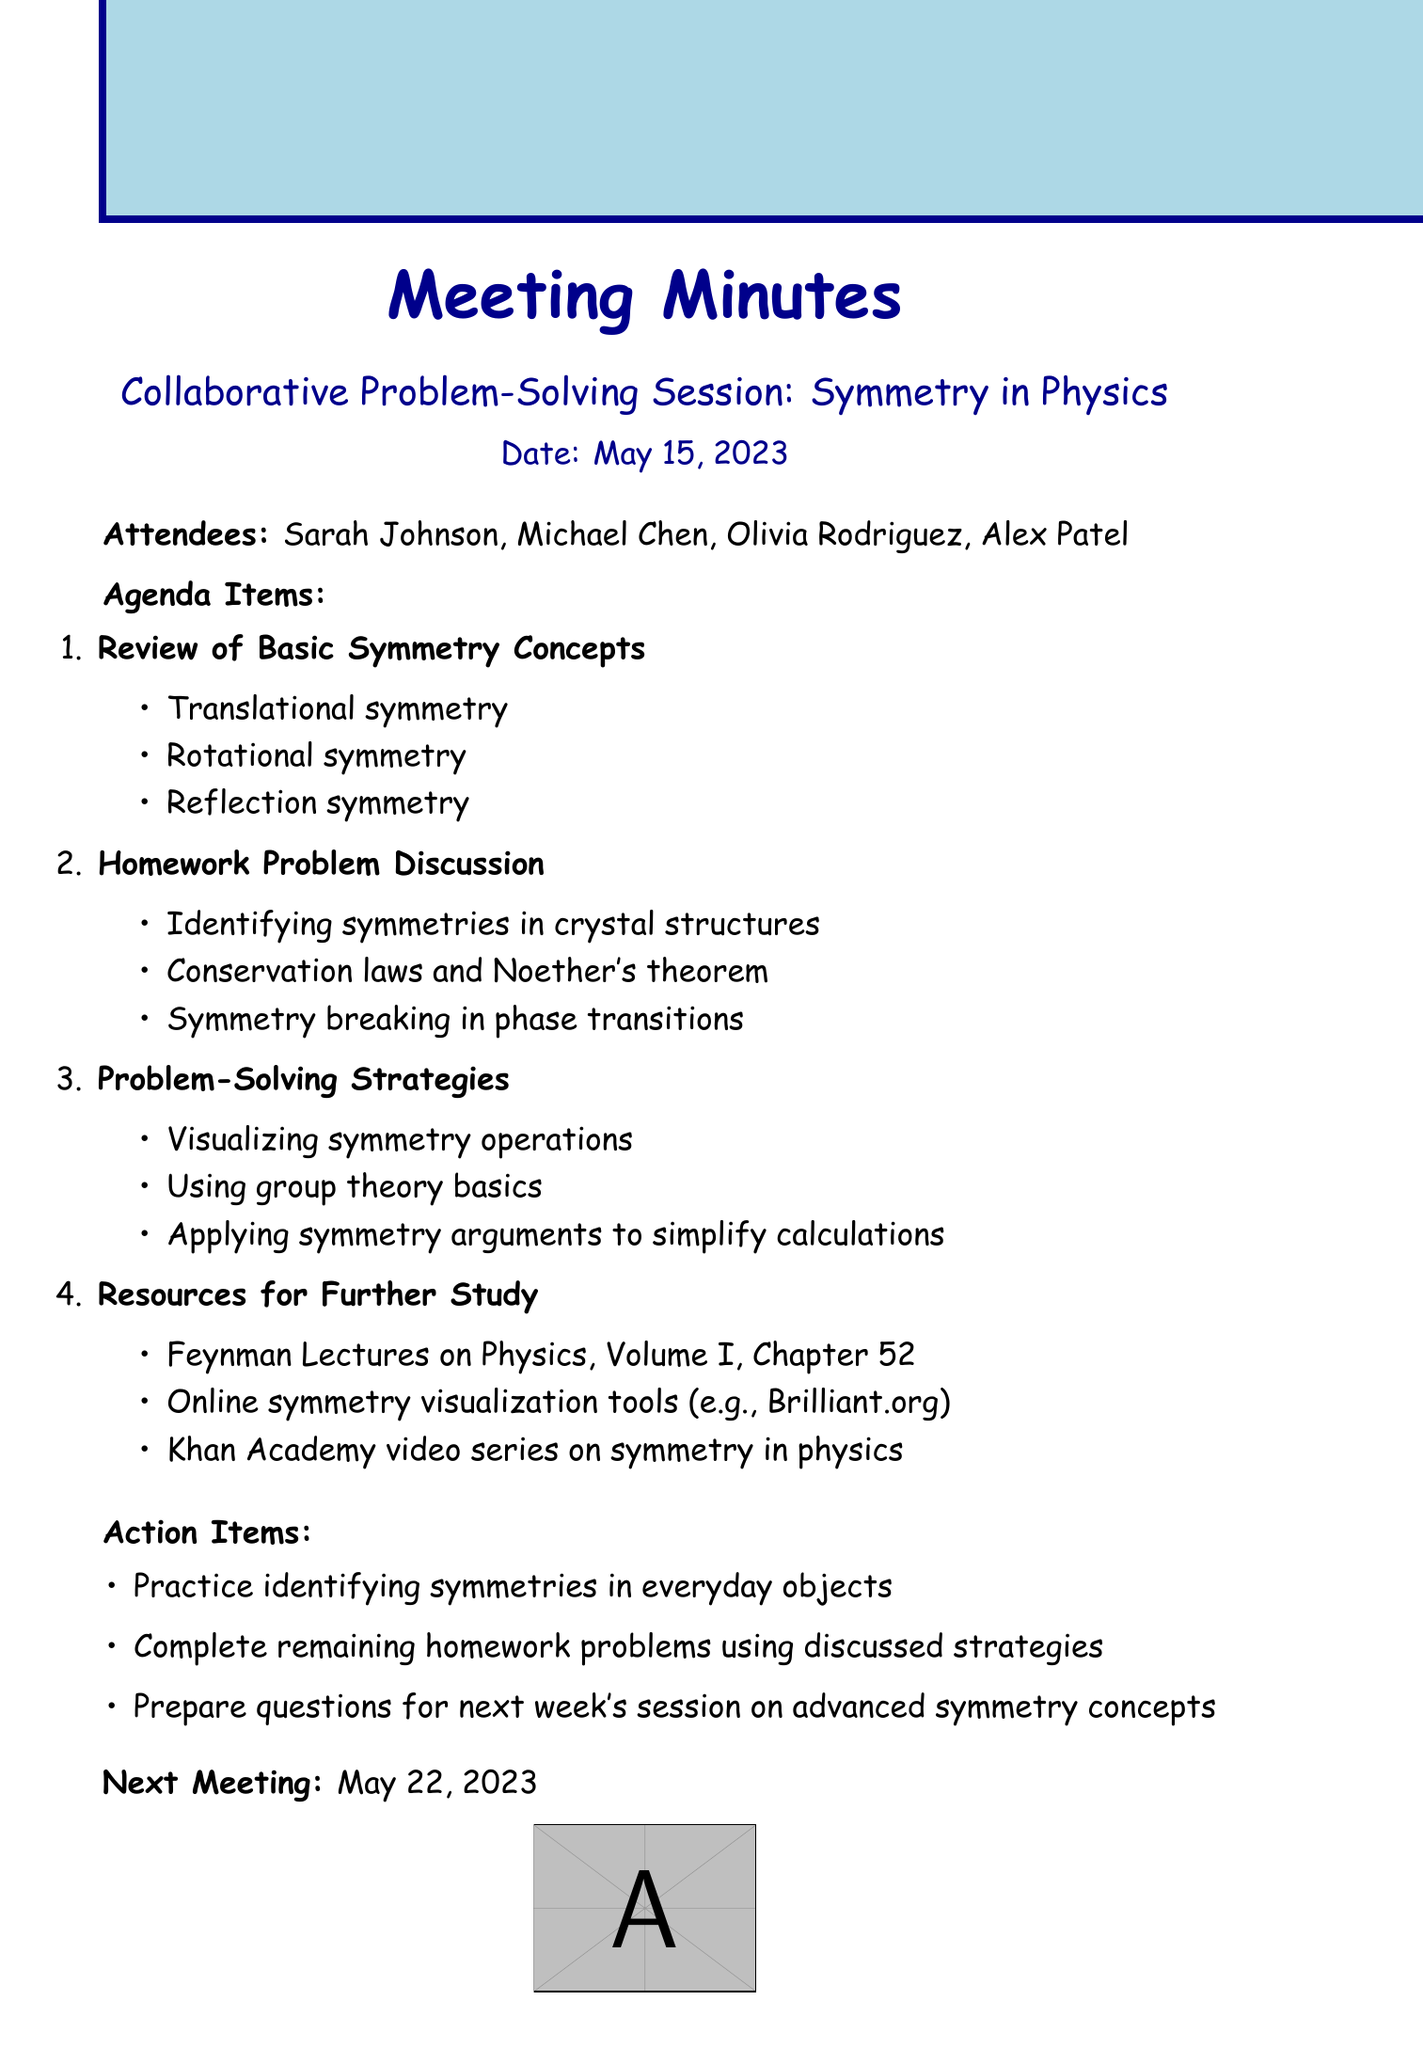What is the title of the meeting? The title is stated clearly at the beginning of the document.
Answer: Collaborative Problem-Solving Session: Symmetry in Physics Who are the attendees of the meeting? The list of attendees is provided in a section clearly labeled "Attendees."
Answer: Sarah Johnson, Michael Chen, Olivia Rodriguez, Alex Patel What date was the meeting held? The date of the meeting is mentioned right after the title.
Answer: May 15, 2023 What is one of the key points discussed in the review of symmetry concepts? The key points are listed under the topic "Review of Basic Symmetry Concepts."
Answer: Translational symmetry Which homework problem discusses conservation laws? The homework problems are listed, and conservation laws are mentioned in one of them.
Answer: Conservation laws and Noether's theorem What resource is suggested for further study on symmetry in physics? The document lists resources for further study under a separate section.
Answer: Feynman Lectures on Physics, Volume I, Chapter 52 What technique can be applied to simplify calculations? The techniques for problem-solving are listed and one of them pertains to calculations.
Answer: Applying symmetry arguments to simplify calculations When is the next meeting scheduled? The next meeting date is clearly mentioned at the end of the document.
Answer: May 22, 2023 What is one action item from the meeting? The action items are listed in a dedicated section towards the end of the document.
Answer: Practice identifying symmetries in everyday objects 